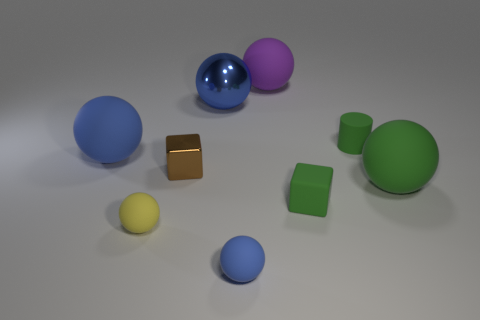There is a matte sphere that is the same color as the tiny cylinder; what is its size?
Make the answer very short. Large. What number of small cylinders have the same color as the tiny rubber cube?
Offer a terse response. 1. There is a shiny object that is behind the brown object; is it the same size as the cube that is to the right of the tiny blue rubber sphere?
Offer a very short reply. No. What is the color of the metallic thing in front of the large blue matte thing that is in front of the green matte cylinder?
Your response must be concise. Brown. There is a cylinder; is its color the same as the cube that is on the right side of the blue shiny sphere?
Provide a succinct answer. Yes. What is the thing that is to the right of the big purple thing and in front of the green matte ball made of?
Offer a very short reply. Rubber. Are there any blue rubber objects that have the same size as the green cylinder?
Your answer should be compact. Yes. There is a purple ball that is the same size as the blue shiny object; what material is it?
Offer a terse response. Rubber. There is a green rubber cylinder; how many green blocks are on the left side of it?
Your answer should be very brief. 1. There is a big rubber object that is on the left side of the large purple sphere; does it have the same shape as the tiny brown shiny thing?
Offer a very short reply. No. 